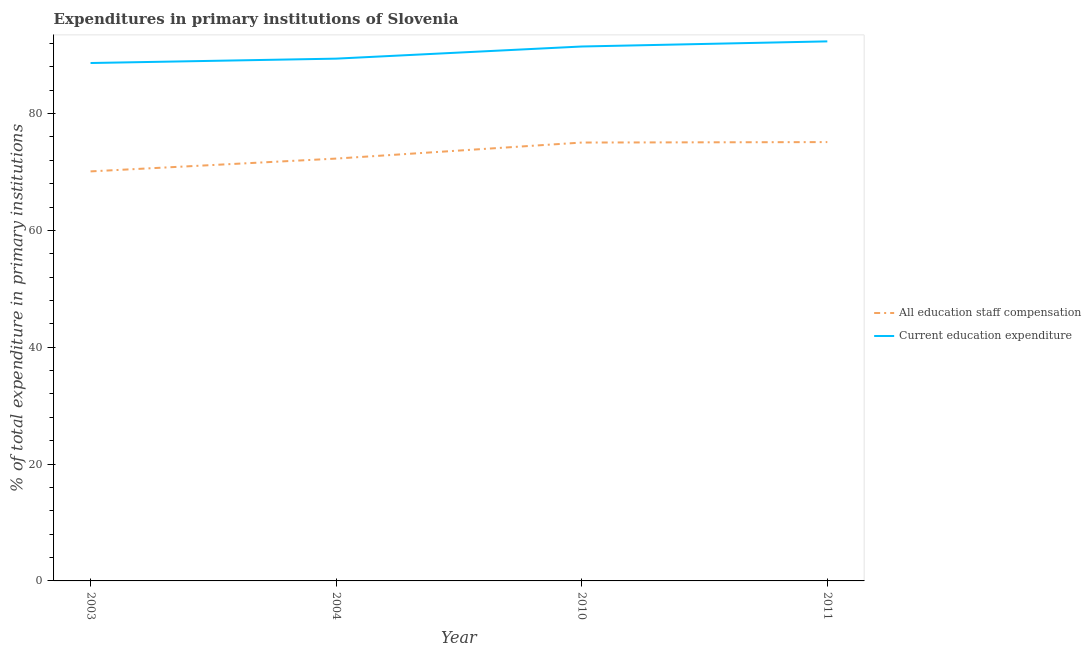Is the number of lines equal to the number of legend labels?
Your answer should be very brief. Yes. What is the expenditure in staff compensation in 2004?
Your answer should be very brief. 72.3. Across all years, what is the maximum expenditure in education?
Make the answer very short. 92.36. Across all years, what is the minimum expenditure in staff compensation?
Provide a succinct answer. 70.1. In which year was the expenditure in staff compensation maximum?
Offer a very short reply. 2011. What is the total expenditure in staff compensation in the graph?
Ensure brevity in your answer.  292.56. What is the difference between the expenditure in staff compensation in 2003 and that in 2004?
Your answer should be compact. -2.19. What is the difference between the expenditure in education in 2003 and the expenditure in staff compensation in 2011?
Give a very brief answer. 13.54. What is the average expenditure in staff compensation per year?
Offer a very short reply. 73.14. In the year 2010, what is the difference between the expenditure in staff compensation and expenditure in education?
Your response must be concise. -16.44. In how many years, is the expenditure in education greater than 88 %?
Give a very brief answer. 4. What is the ratio of the expenditure in staff compensation in 2003 to that in 2010?
Offer a terse response. 0.93. Is the difference between the expenditure in staff compensation in 2003 and 2010 greater than the difference between the expenditure in education in 2003 and 2010?
Keep it short and to the point. No. What is the difference between the highest and the second highest expenditure in education?
Provide a succinct answer. 0.88. What is the difference between the highest and the lowest expenditure in staff compensation?
Your answer should be very brief. 5.02. Is the sum of the expenditure in staff compensation in 2004 and 2010 greater than the maximum expenditure in education across all years?
Provide a short and direct response. Yes. Does the expenditure in education monotonically increase over the years?
Offer a terse response. Yes. What is the difference between two consecutive major ticks on the Y-axis?
Give a very brief answer. 20. Are the values on the major ticks of Y-axis written in scientific E-notation?
Ensure brevity in your answer.  No. Does the graph contain grids?
Provide a succinct answer. No. Where does the legend appear in the graph?
Keep it short and to the point. Center right. How are the legend labels stacked?
Your response must be concise. Vertical. What is the title of the graph?
Keep it short and to the point. Expenditures in primary institutions of Slovenia. Does "Excluding technical cooperation" appear as one of the legend labels in the graph?
Offer a terse response. No. What is the label or title of the X-axis?
Your answer should be very brief. Year. What is the label or title of the Y-axis?
Your answer should be compact. % of total expenditure in primary institutions. What is the % of total expenditure in primary institutions of All education staff compensation in 2003?
Keep it short and to the point. 70.1. What is the % of total expenditure in primary institutions of Current education expenditure in 2003?
Make the answer very short. 88.66. What is the % of total expenditure in primary institutions in All education staff compensation in 2004?
Ensure brevity in your answer.  72.3. What is the % of total expenditure in primary institutions of Current education expenditure in 2004?
Your answer should be very brief. 89.4. What is the % of total expenditure in primary institutions in All education staff compensation in 2010?
Offer a very short reply. 75.04. What is the % of total expenditure in primary institutions in Current education expenditure in 2010?
Ensure brevity in your answer.  91.48. What is the % of total expenditure in primary institutions of All education staff compensation in 2011?
Keep it short and to the point. 75.12. What is the % of total expenditure in primary institutions in Current education expenditure in 2011?
Provide a short and direct response. 92.36. Across all years, what is the maximum % of total expenditure in primary institutions of All education staff compensation?
Your answer should be compact. 75.12. Across all years, what is the maximum % of total expenditure in primary institutions of Current education expenditure?
Your response must be concise. 92.36. Across all years, what is the minimum % of total expenditure in primary institutions in All education staff compensation?
Your answer should be very brief. 70.1. Across all years, what is the minimum % of total expenditure in primary institutions of Current education expenditure?
Give a very brief answer. 88.66. What is the total % of total expenditure in primary institutions in All education staff compensation in the graph?
Your answer should be very brief. 292.56. What is the total % of total expenditure in primary institutions in Current education expenditure in the graph?
Your answer should be compact. 361.9. What is the difference between the % of total expenditure in primary institutions of All education staff compensation in 2003 and that in 2004?
Your answer should be compact. -2.19. What is the difference between the % of total expenditure in primary institutions in Current education expenditure in 2003 and that in 2004?
Give a very brief answer. -0.75. What is the difference between the % of total expenditure in primary institutions in All education staff compensation in 2003 and that in 2010?
Make the answer very short. -4.94. What is the difference between the % of total expenditure in primary institutions of Current education expenditure in 2003 and that in 2010?
Provide a short and direct response. -2.83. What is the difference between the % of total expenditure in primary institutions of All education staff compensation in 2003 and that in 2011?
Your response must be concise. -5.02. What is the difference between the % of total expenditure in primary institutions of Current education expenditure in 2003 and that in 2011?
Make the answer very short. -3.7. What is the difference between the % of total expenditure in primary institutions of All education staff compensation in 2004 and that in 2010?
Ensure brevity in your answer.  -2.75. What is the difference between the % of total expenditure in primary institutions in Current education expenditure in 2004 and that in 2010?
Give a very brief answer. -2.08. What is the difference between the % of total expenditure in primary institutions of All education staff compensation in 2004 and that in 2011?
Provide a short and direct response. -2.82. What is the difference between the % of total expenditure in primary institutions in Current education expenditure in 2004 and that in 2011?
Keep it short and to the point. -2.96. What is the difference between the % of total expenditure in primary institutions in All education staff compensation in 2010 and that in 2011?
Make the answer very short. -0.08. What is the difference between the % of total expenditure in primary institutions of Current education expenditure in 2010 and that in 2011?
Provide a short and direct response. -0.88. What is the difference between the % of total expenditure in primary institutions in All education staff compensation in 2003 and the % of total expenditure in primary institutions in Current education expenditure in 2004?
Your answer should be very brief. -19.3. What is the difference between the % of total expenditure in primary institutions of All education staff compensation in 2003 and the % of total expenditure in primary institutions of Current education expenditure in 2010?
Your response must be concise. -21.38. What is the difference between the % of total expenditure in primary institutions of All education staff compensation in 2003 and the % of total expenditure in primary institutions of Current education expenditure in 2011?
Offer a terse response. -22.26. What is the difference between the % of total expenditure in primary institutions of All education staff compensation in 2004 and the % of total expenditure in primary institutions of Current education expenditure in 2010?
Your answer should be very brief. -19.19. What is the difference between the % of total expenditure in primary institutions of All education staff compensation in 2004 and the % of total expenditure in primary institutions of Current education expenditure in 2011?
Offer a terse response. -20.06. What is the difference between the % of total expenditure in primary institutions in All education staff compensation in 2010 and the % of total expenditure in primary institutions in Current education expenditure in 2011?
Your response must be concise. -17.32. What is the average % of total expenditure in primary institutions in All education staff compensation per year?
Your answer should be very brief. 73.14. What is the average % of total expenditure in primary institutions in Current education expenditure per year?
Give a very brief answer. 90.47. In the year 2003, what is the difference between the % of total expenditure in primary institutions in All education staff compensation and % of total expenditure in primary institutions in Current education expenditure?
Your answer should be very brief. -18.55. In the year 2004, what is the difference between the % of total expenditure in primary institutions of All education staff compensation and % of total expenditure in primary institutions of Current education expenditure?
Provide a short and direct response. -17.11. In the year 2010, what is the difference between the % of total expenditure in primary institutions of All education staff compensation and % of total expenditure in primary institutions of Current education expenditure?
Your answer should be very brief. -16.44. In the year 2011, what is the difference between the % of total expenditure in primary institutions in All education staff compensation and % of total expenditure in primary institutions in Current education expenditure?
Keep it short and to the point. -17.24. What is the ratio of the % of total expenditure in primary institutions of All education staff compensation in 2003 to that in 2004?
Your answer should be compact. 0.97. What is the ratio of the % of total expenditure in primary institutions in All education staff compensation in 2003 to that in 2010?
Make the answer very short. 0.93. What is the ratio of the % of total expenditure in primary institutions in Current education expenditure in 2003 to that in 2010?
Provide a short and direct response. 0.97. What is the ratio of the % of total expenditure in primary institutions in All education staff compensation in 2003 to that in 2011?
Give a very brief answer. 0.93. What is the ratio of the % of total expenditure in primary institutions of Current education expenditure in 2003 to that in 2011?
Offer a terse response. 0.96. What is the ratio of the % of total expenditure in primary institutions in All education staff compensation in 2004 to that in 2010?
Provide a succinct answer. 0.96. What is the ratio of the % of total expenditure in primary institutions of Current education expenditure in 2004 to that in 2010?
Give a very brief answer. 0.98. What is the ratio of the % of total expenditure in primary institutions in All education staff compensation in 2004 to that in 2011?
Your answer should be compact. 0.96. What is the difference between the highest and the second highest % of total expenditure in primary institutions in All education staff compensation?
Provide a short and direct response. 0.08. What is the difference between the highest and the second highest % of total expenditure in primary institutions of Current education expenditure?
Give a very brief answer. 0.88. What is the difference between the highest and the lowest % of total expenditure in primary institutions in All education staff compensation?
Provide a succinct answer. 5.02. What is the difference between the highest and the lowest % of total expenditure in primary institutions in Current education expenditure?
Ensure brevity in your answer.  3.7. 